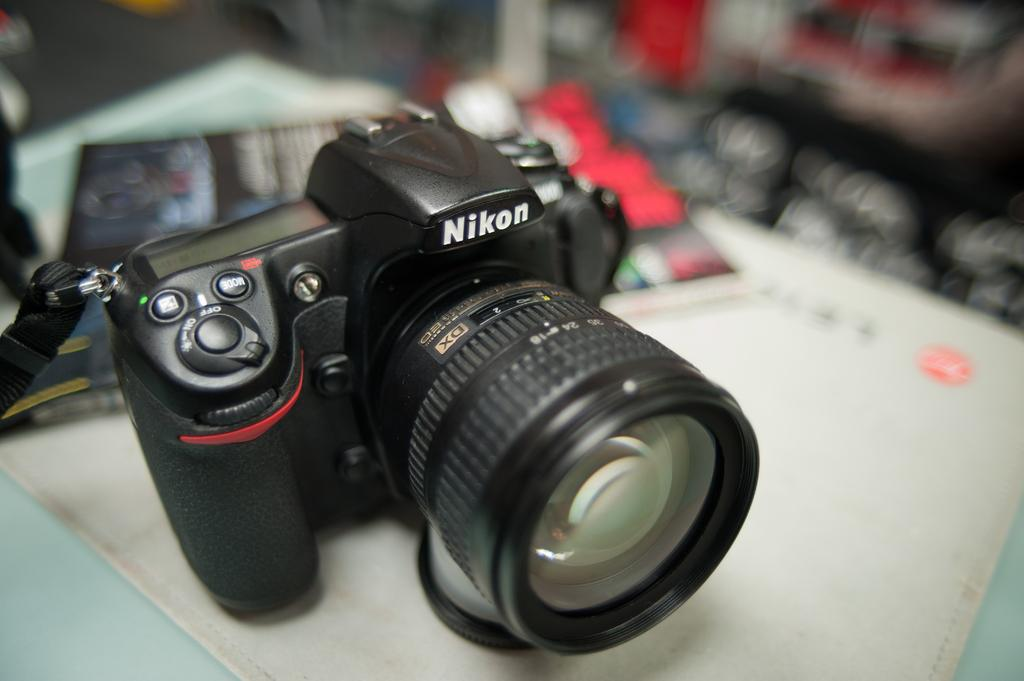What is the main object in the image? There is a camera in the image. What else can be seen in the image besides the camera? There are books in the image. Where are the books and camera located? The books and camera are on a platform. How would you describe the background of the image? The background of the image is blurry. How is the honey being distributed in the image? There is no honey present in the image, so it cannot be distributed. 